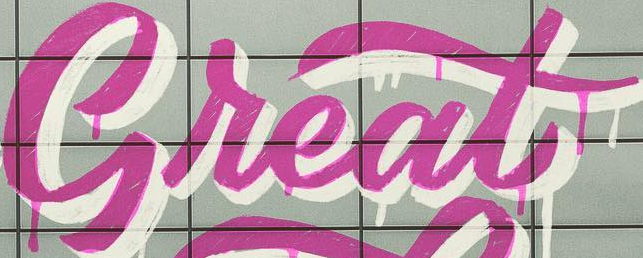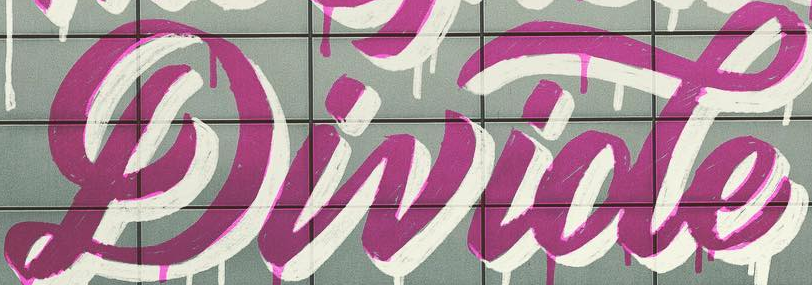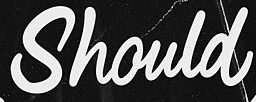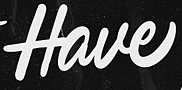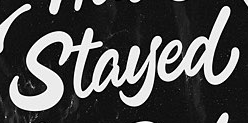What words are shown in these images in order, separated by a semicolon? Great; Divide; Should; Have; Stayed 